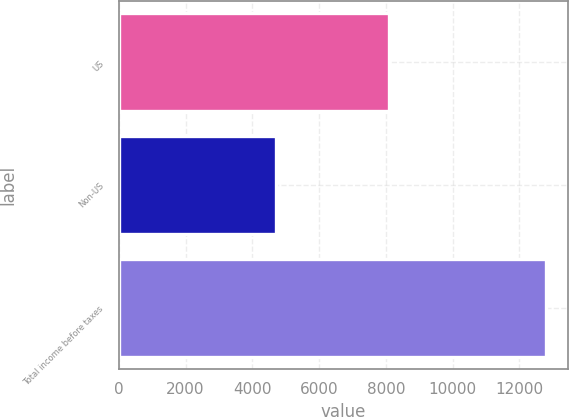Convert chart to OTSL. <chart><loc_0><loc_0><loc_500><loc_500><bar_chart><fcel>US<fcel>Non-US<fcel>Total income before taxes<nl><fcel>8088<fcel>4718<fcel>12806<nl></chart> 